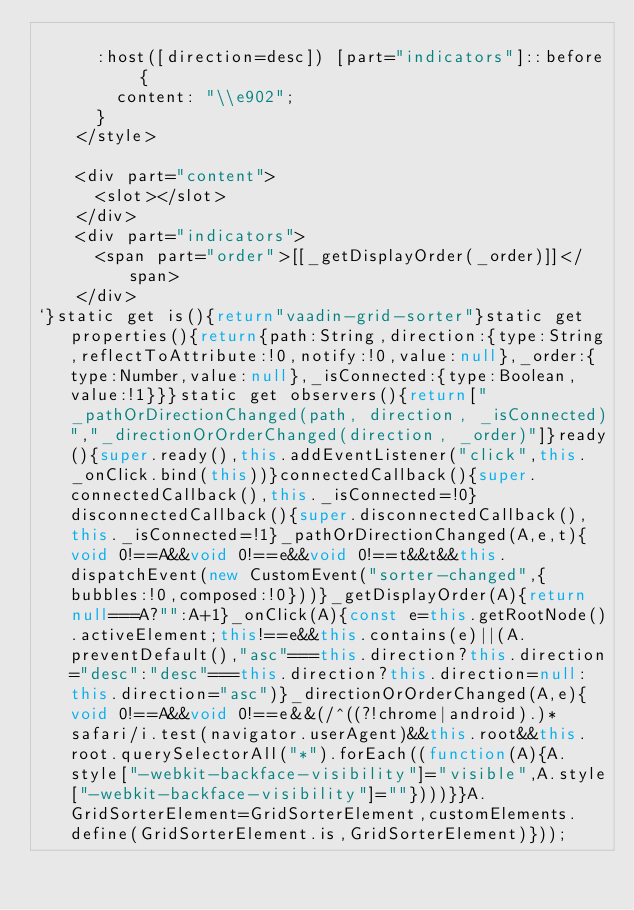<code> <loc_0><loc_0><loc_500><loc_500><_JavaScript_>
      :host([direction=desc]) [part="indicators"]::before {
        content: "\\e902";
      }
    </style>

    <div part="content">
      <slot></slot>
    </div>
    <div part="indicators">
      <span part="order">[[_getDisplayOrder(_order)]]</span>
    </div>
`}static get is(){return"vaadin-grid-sorter"}static get properties(){return{path:String,direction:{type:String,reflectToAttribute:!0,notify:!0,value:null},_order:{type:Number,value:null},_isConnected:{type:Boolean,value:!1}}}static get observers(){return["_pathOrDirectionChanged(path, direction, _isConnected)","_directionOrOrderChanged(direction, _order)"]}ready(){super.ready(),this.addEventListener("click",this._onClick.bind(this))}connectedCallback(){super.connectedCallback(),this._isConnected=!0}disconnectedCallback(){super.disconnectedCallback(),this._isConnected=!1}_pathOrDirectionChanged(A,e,t){void 0!==A&&void 0!==e&&void 0!==t&&t&&this.dispatchEvent(new CustomEvent("sorter-changed",{bubbles:!0,composed:!0}))}_getDisplayOrder(A){return null===A?"":A+1}_onClick(A){const e=this.getRootNode().activeElement;this!==e&&this.contains(e)||(A.preventDefault(),"asc"===this.direction?this.direction="desc":"desc"===this.direction?this.direction=null:this.direction="asc")}_directionOrOrderChanged(A,e){void 0!==A&&void 0!==e&&(/^((?!chrome|android).)*safari/i.test(navigator.userAgent)&&this.root&&this.root.querySelectorAll("*").forEach((function(A){A.style["-webkit-backface-visibility"]="visible",A.style["-webkit-backface-visibility"]=""})))}}A.GridSorterElement=GridSorterElement,customElements.define(GridSorterElement.is,GridSorterElement)}));</code> 